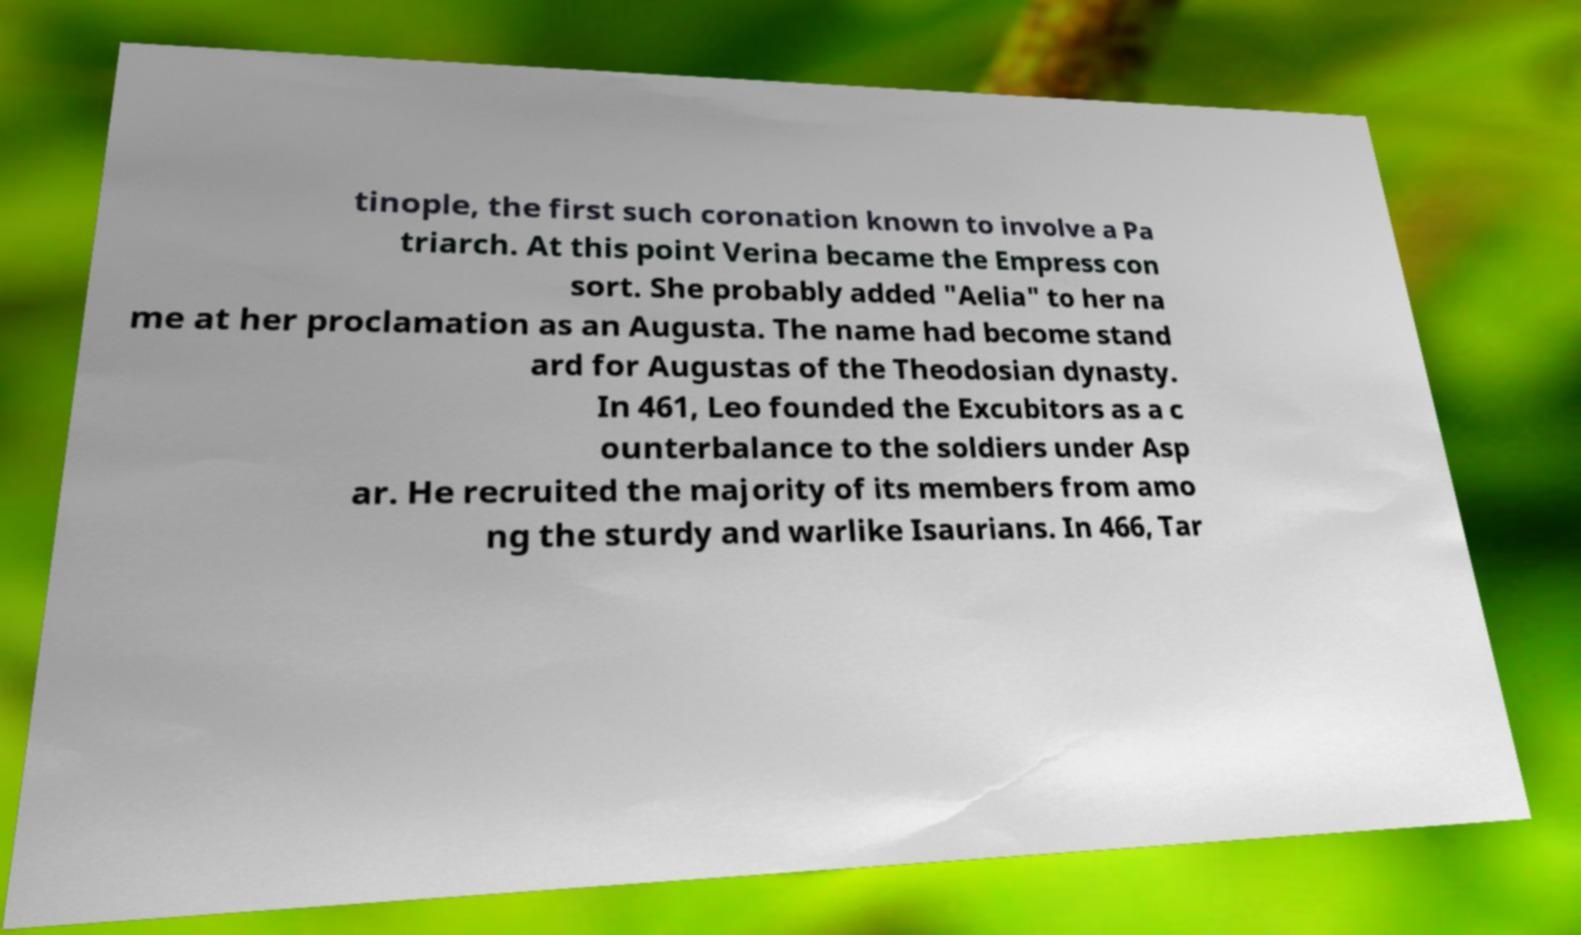Can you accurately transcribe the text from the provided image for me? tinople, the first such coronation known to involve a Pa triarch. At this point Verina became the Empress con sort. She probably added "Aelia" to her na me at her proclamation as an Augusta. The name had become stand ard for Augustas of the Theodosian dynasty. In 461, Leo founded the Excubitors as a c ounterbalance to the soldiers under Asp ar. He recruited the majority of its members from amo ng the sturdy and warlike Isaurians. In 466, Tar 